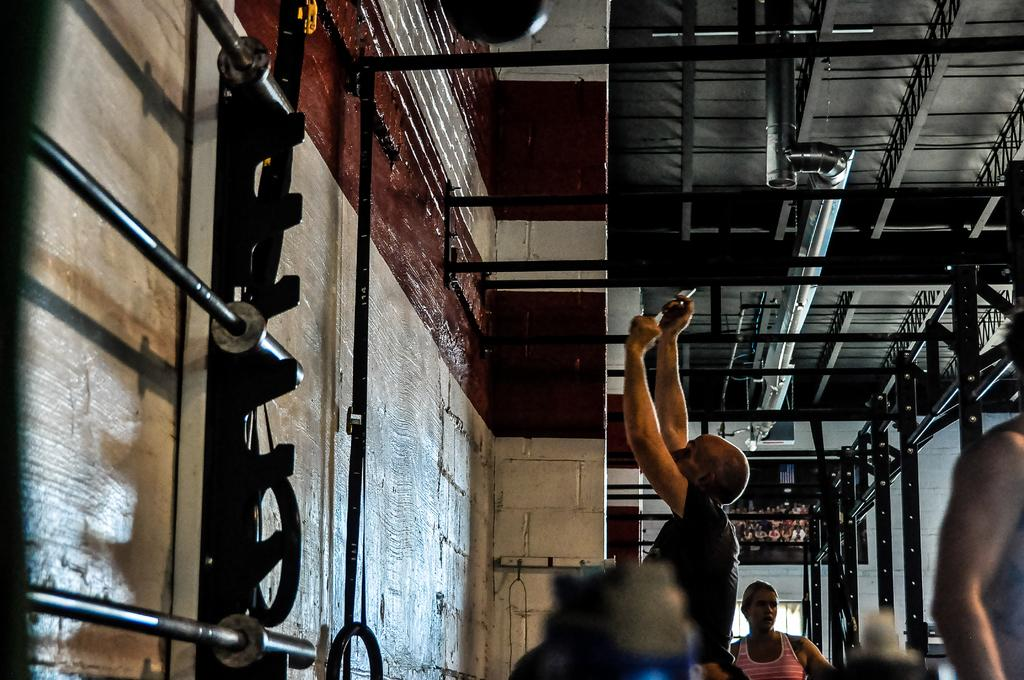How many people are in the image? There are three persons in the image. What objects can be seen in the image besides the people? There are rods visible in the image. What type of structures are present in the image? There are walls in the image. What part of the room is visible in the image? The ceiling is visible in the image. What type of cake is being served on the table in the image? There is no table or cake present in the image. How many eggs are visible in the image? There are no eggs visible in the image. 